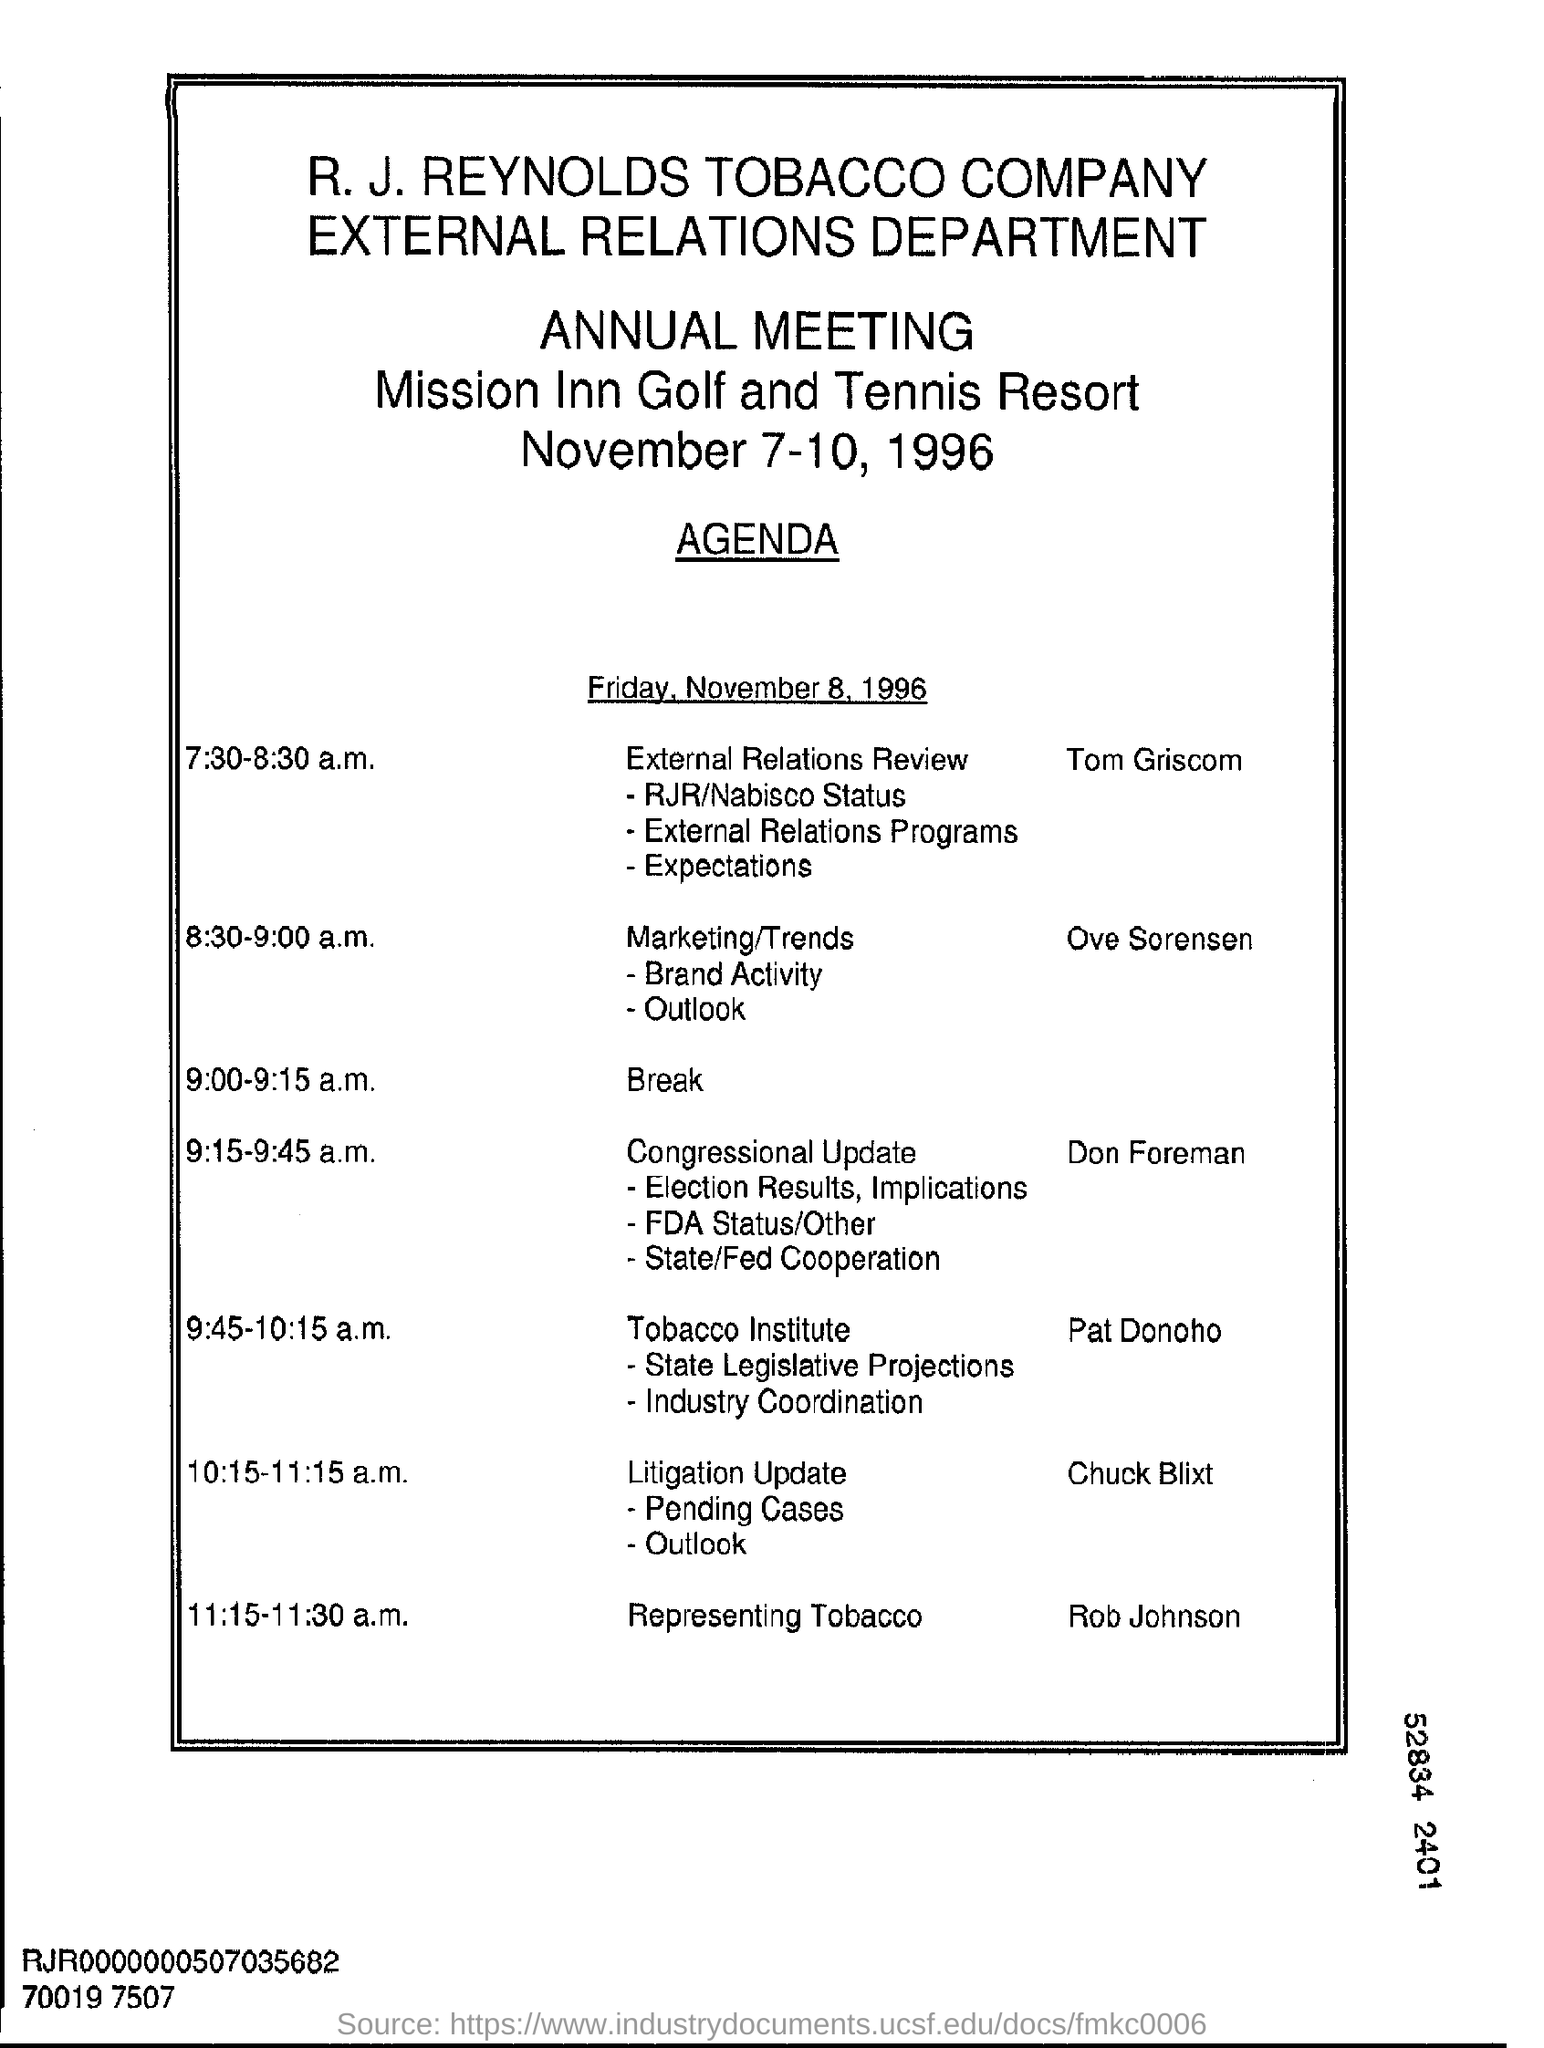Outline some significant characteristics in this image. The company listed on the letterhead is R. J. Reynolds Tobacco Company. The timing of the meeting for the external relations review is from 7:30 to 8:30 in the morning. The person who represented the tobacco in the meeting was Rob Johnson. At 8:30-9:00 am, the marketing/trends discussion was led by Ove Sorensen. The break time for the annual meeting is scheduled from 9:00 to 9:15 a.m. 